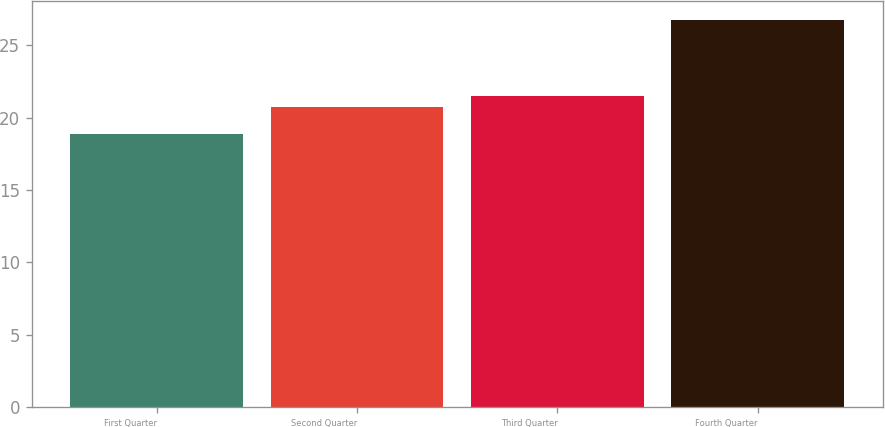Convert chart. <chart><loc_0><loc_0><loc_500><loc_500><bar_chart><fcel>First Quarter<fcel>Second Quarter<fcel>Third Quarter<fcel>Fourth Quarter<nl><fcel>18.87<fcel>20.7<fcel>21.49<fcel>26.73<nl></chart> 